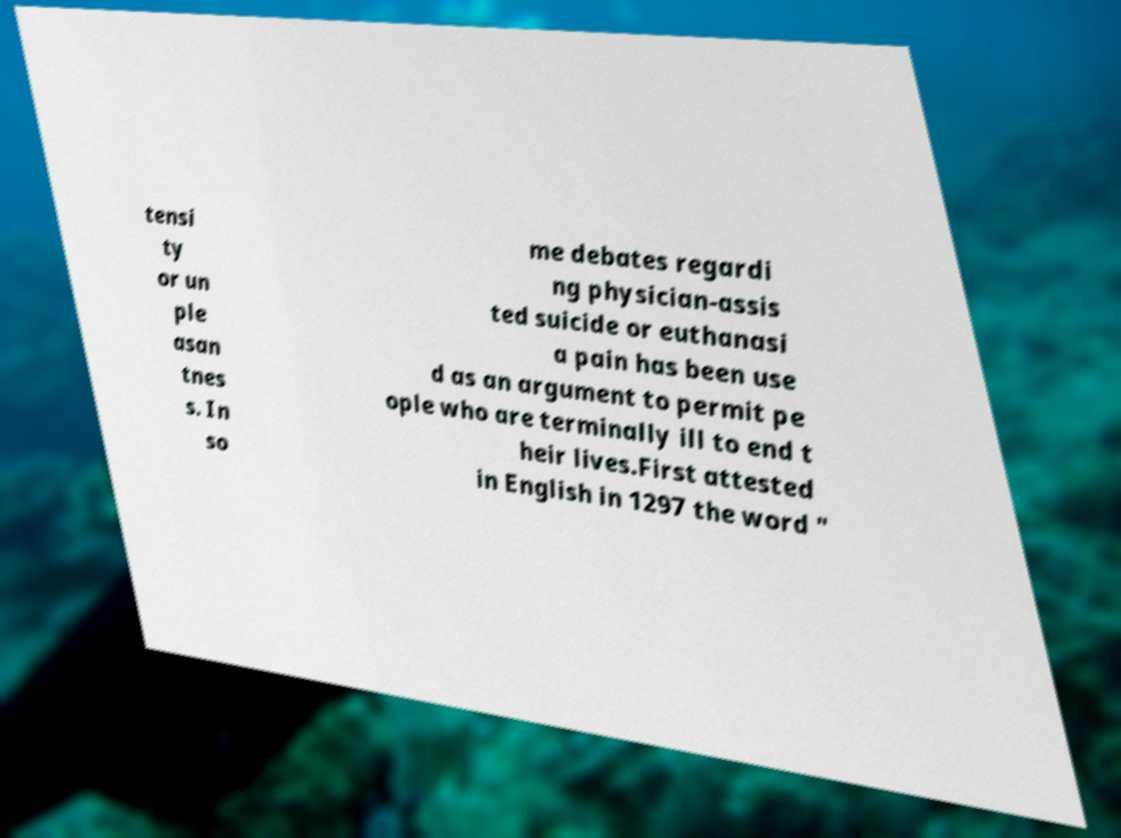Please identify and transcribe the text found in this image. tensi ty or un ple asan tnes s. In so me debates regardi ng physician-assis ted suicide or euthanasi a pain has been use d as an argument to permit pe ople who are terminally ill to end t heir lives.First attested in English in 1297 the word " 